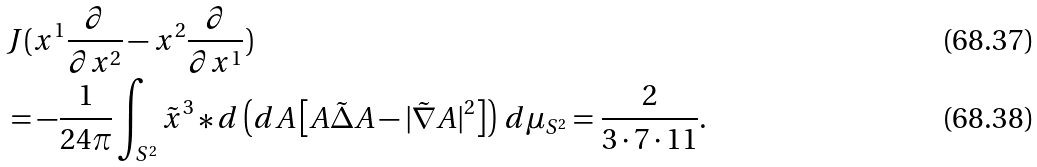Convert formula to latex. <formula><loc_0><loc_0><loc_500><loc_500>& J ( x ^ { 1 } \frac { \partial } { \partial x ^ { 2 } } - x ^ { 2 } \frac { \partial } { \partial x ^ { 1 } } ) \\ & = - \frac { 1 } { 2 4 \pi } \int _ { S ^ { 2 } } \tilde { x } ^ { 3 } * d \left ( d A \left [ A { \tilde { \Delta } } A - | { \tilde { \nabla } } A | ^ { 2 } \right ] \right ) \, d \mu _ { S ^ { 2 } } = \frac { 2 } { 3 \cdot 7 \cdot 1 1 } .</formula> 